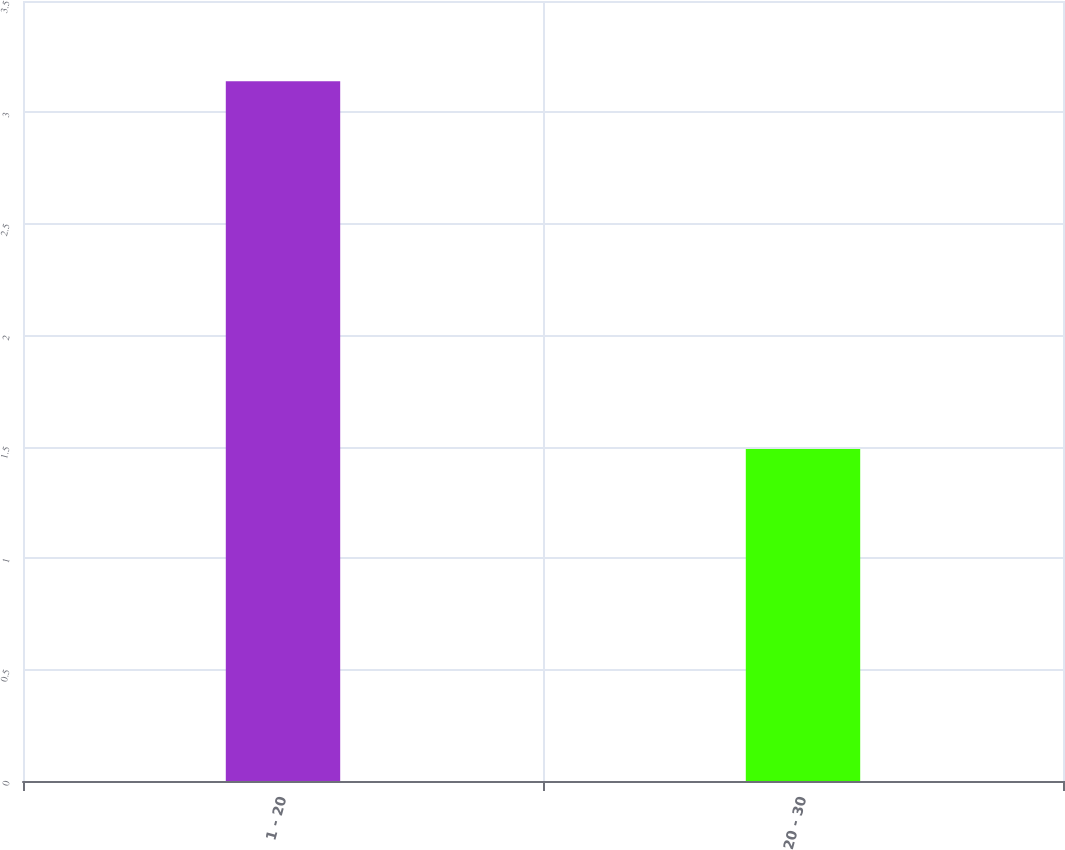Convert chart. <chart><loc_0><loc_0><loc_500><loc_500><bar_chart><fcel>1 - 20<fcel>20 - 30<nl><fcel>3.14<fcel>1.49<nl></chart> 